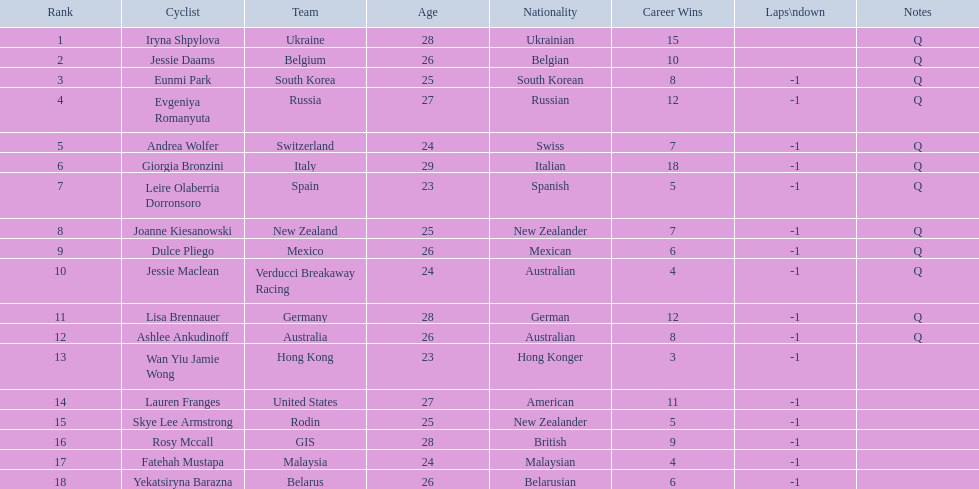Can you parse all the data within this table? {'header': ['Rank', 'Cyclist', 'Team', 'Age', 'Nationality', 'Career Wins', 'Laps\\ndown', 'Notes'], 'rows': [['1', 'Iryna Shpylova', 'Ukraine', '28', 'Ukrainian', '15', '', 'Q'], ['2', 'Jessie Daams', 'Belgium', '26', 'Belgian', '10', '', 'Q'], ['3', 'Eunmi Park', 'South Korea', '25', 'South Korean', '8', '-1', 'Q'], ['4', 'Evgeniya Romanyuta', 'Russia', '27', 'Russian', '12', '-1', 'Q'], ['5', 'Andrea Wolfer', 'Switzerland', '24', 'Swiss', '7', '-1', 'Q'], ['6', 'Giorgia Bronzini', 'Italy', '29', 'Italian', '18', '-1', 'Q'], ['7', 'Leire Olaberria Dorronsoro', 'Spain', '23', 'Spanish', '5', '-1', 'Q'], ['8', 'Joanne Kiesanowski', 'New Zealand', '25', 'New Zealander', '7', '-1', 'Q'], ['9', 'Dulce Pliego', 'Mexico', '26', 'Mexican', '6', '-1', 'Q'], ['10', 'Jessie Maclean', 'Verducci Breakaway Racing', '24', 'Australian', '4', '-1', 'Q'], ['11', 'Lisa Brennauer', 'Germany', '28', 'German', '12', '-1', 'Q'], ['12', 'Ashlee Ankudinoff', 'Australia', '26', 'Australian', '8', '-1', 'Q'], ['13', 'Wan Yiu Jamie Wong', 'Hong Kong', '23', 'Hong Konger', '3', '-1', ''], ['14', 'Lauren Franges', 'United States', '27', 'American', '11', '-1', ''], ['15', 'Skye Lee Armstrong', 'Rodin', '25', 'New Zealander', '5', '-1', ''], ['16', 'Rosy Mccall', 'GIS', '28', 'British', '9', '-1', ''], ['17', 'Fatehah Mustapa', 'Malaysia', '24', 'Malaysian', '4', '-1', ''], ['18', 'Yekatsiryna Barazna', 'Belarus', '26', 'Belarusian', '6', '-1', '']]} Who was the initial participant to complete the race with a one-lap deficit? Eunmi Park. 